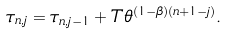Convert formula to latex. <formula><loc_0><loc_0><loc_500><loc_500>\tau _ { n , j } & = \tau _ { n , j - 1 } + T \theta ^ { ( 1 - \beta ) ( n + 1 - j ) } .</formula> 